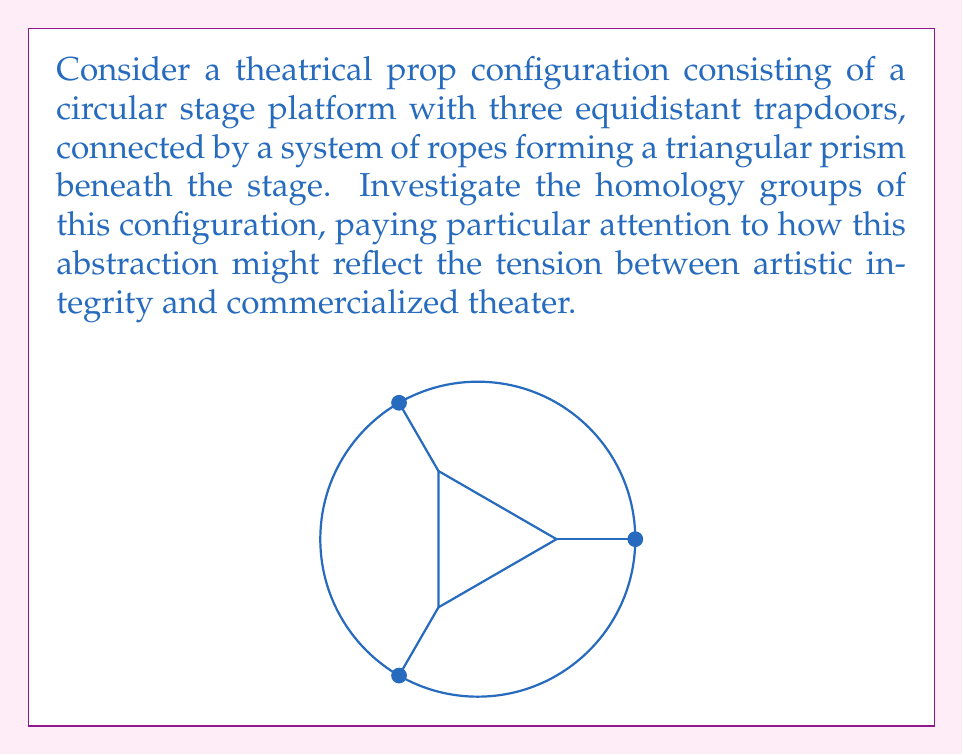Can you answer this question? To investigate the homology groups of this configuration, we'll follow these steps:

1) Identify the topological space:
   The space is essentially a solid circular disk (the stage) with three points removed (the trapdoors), connected to a triangular prism beneath.

2) Simplify the space:
   This configuration is homotopy equivalent to a wedge sum of a circle and three line segments. The circle represents the boundary of the stage, and the three line segments represent the ropes connecting the trapdoors to the base of the prism.

3) Calculate the homology groups:
   For a wedge sum, we can use the reduced homology groups and the fact that $\tilde{H}_n(X \vee Y) \cong \tilde{H}_n(X) \oplus \tilde{H}_n(Y)$ for $n \geq 1$.

   a) For the circle $S^1$:
      $\tilde{H}_0(S^1) = 0$
      $\tilde{H}_1(S^1) = \mathbb{Z}$
      $\tilde{H}_n(S^1) = 0$ for $n \geq 2$

   b) For each line segment (homeomorphic to a point):
      $\tilde{H}_n(\text{point}) = 0$ for all $n$

4) Combine the results:
   $H_0(X) = \mathbb{Z}$ (connected space)
   $H_1(X) = \mathbb{Z}$ (from the circle)
   $H_n(X) = 0$ for $n \geq 2$

5) Interpretation:
   The non-trivial first homology group ($H_1 = \mathbb{Z}$) represents the circular nature of the stage, which could be seen as a metaphor for the cyclical nature of theatrical traditions. The absence of higher homology groups might reflect the simplification often found in commercialized theater, stripping away complexity for mass appeal.
Answer: $H_0(X) = \mathbb{Z}, H_1(X) = \mathbb{Z}, H_n(X) = 0$ for $n \geq 2$ 